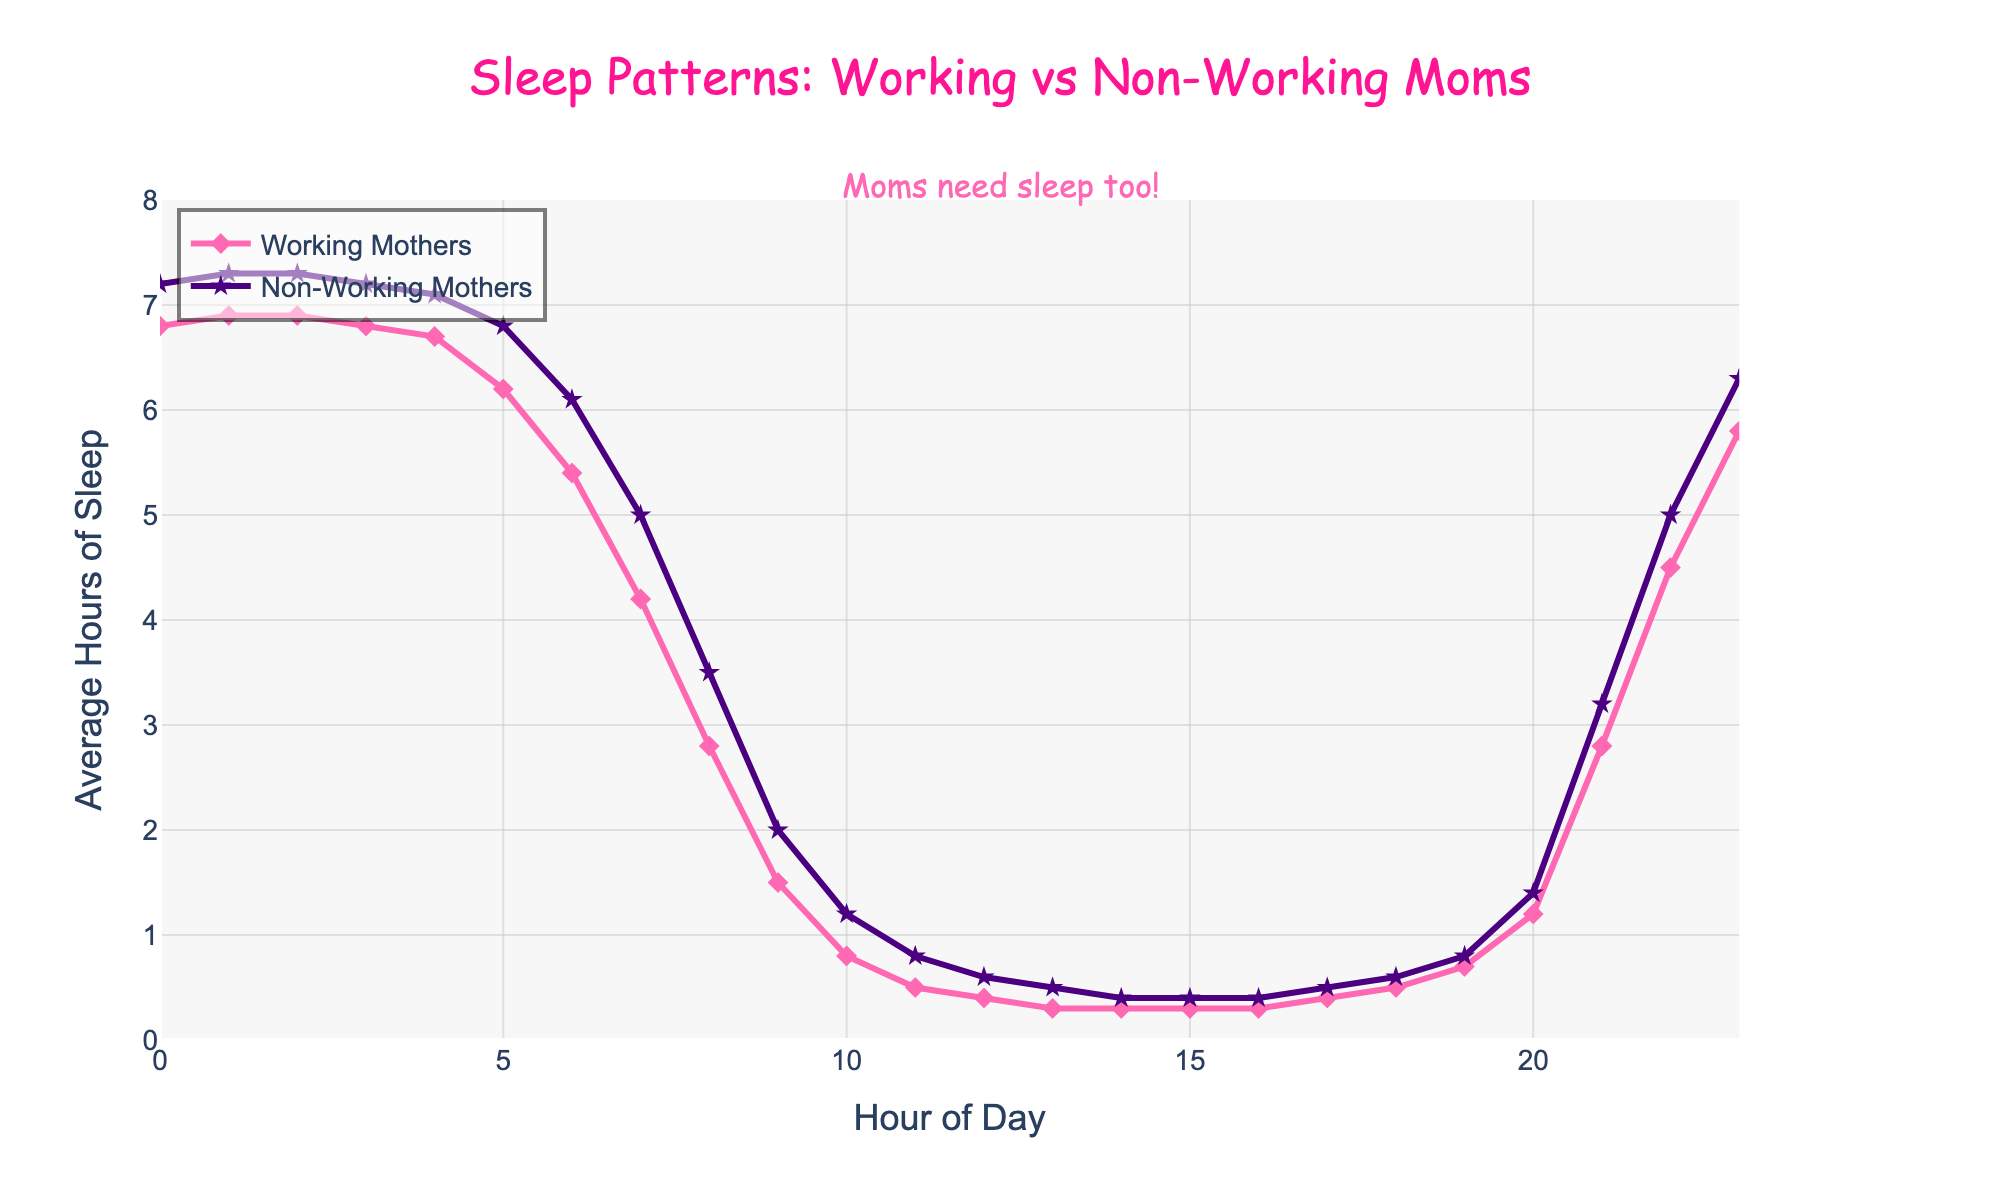What's the duration when both groups get their minimum average sleep? For both groups, the minimum average hours of sleep can be observed between 11 AM and 5 PM. By comparing the values in this interval, we can see that the lowest number for Working Mothers occurs at 1 PM and for Non-Working Mothers at 2 PM
Answer: 0.3 hours Between which hours is the difference in sleep hours the greatest? By examining the plot, the largest difference occurs between 7 AM and 8 AM where Working Mothers have 4.2 hours of sleep decrementing to 2.8, while Non-Working Mothers have 5.0 reducing to 3.5 resulting in the greatest difference
Answer: 7 AM to 8 AM What's the average hours of sleep for Working Mothers between 8 PM and 10 PM? Checking the data between these hours (8 PM is at 20, 9 PM is at 21, and 10 PM is at 22), the values are 1.2, 2.8, and 4.5 respectively. Adding them up gives 8.5; dividing by 3 results in the average
Answer: 2.83 hours Which group gets more sleep on average between 5 AM and 6 AM? Comparing the values at 5 AM (6.2 for Working Mothers and 6.8 for Non-Working Mothers) and 6 AM (5.4 for Working Mothers and 6.1 for Non-Working Mothers), it's evident that Non-Working Mothers get more average sleep
Answer: Non-Working Mothers At which hour do Non-Working Mothers reach their peak average sleep? By observing the highest plotted point in the data for Non-Working Mothers, it is visible at the hour of 1 AM
Answer: 1 AM What's the total hours of sleep Working Mothers and Non-Working Mothers get at 3 PM combined? Working Mothers have 0.3 hours and Non-Working Mothers also have 0.4 hours, adding these together results in a total of 0.7 hours
Answer: 0.7 hours During what hours do both groups experience a sharp decline in sleep? Looking at the plot, both groups experience the sharpest decline in sleep starting from 6 AM through to 9 AM, where sleep drops rapidly
Answer: 6 AM to 9 AM When do Working Mothers have a sudden increase in sleep? The plot shows a noticeable incline in sleep for Working Mothers starting from 9 PM to 10 PM, with values going from 2.8 to 4.5 hours
Answer: 9 PM to 10 PM What is the biggest difference in sleep between the two groups? The biggest difference can be observed at 7 AM where Working Mothers have 4.2 hours, and Non-Working Mothers have 5.0 hours; the difference is 0.8 hours
Answer: 0.8 hours Which group has a higher average sleep during midnight? Checking the data at midnight (0 AM), we see that Working Mothers have 6.8 hours of sleep and Non-Working Mothers have 7.2 hours, showing that Non-Working Mothers have more sleep
Answer: Non-Working Mothers 